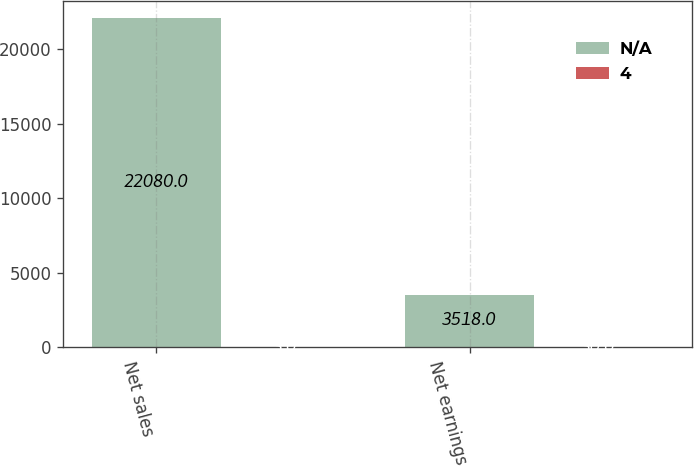Convert chart to OTSL. <chart><loc_0><loc_0><loc_500><loc_500><stacked_bar_chart><ecel><fcel>Net sales<fcel>Net earnings<nl><fcel>nan<fcel>22080<fcel>3518<nl><fcel>4<fcel>3<fcel>30<nl></chart> 